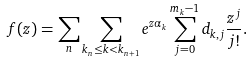Convert formula to latex. <formula><loc_0><loc_0><loc_500><loc_500>f ( z ) = \sum _ { n } \sum _ { k _ { n } \leq k < k _ { n + 1 } } e ^ { z \alpha _ { k } } \sum _ { j = 0 } ^ { m _ { k } - 1 } d _ { k , j } \frac { z ^ { j } } { j ! } .</formula> 